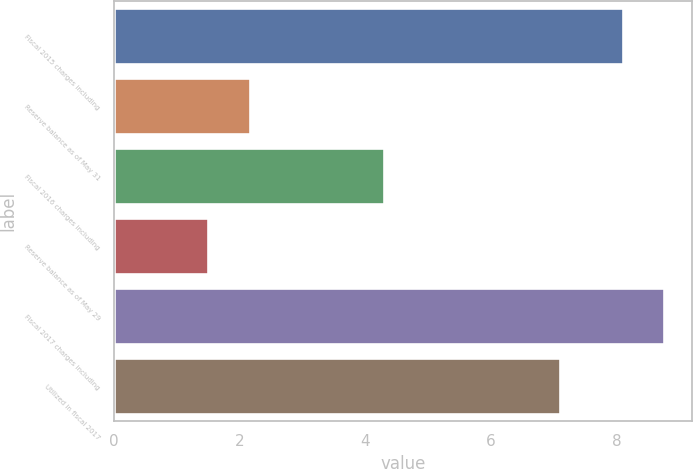<chart> <loc_0><loc_0><loc_500><loc_500><bar_chart><fcel>Fiscal 2015 charges including<fcel>Reserve balance as of May 31<fcel>Fiscal 2016 charges including<fcel>Reserve balance as of May 29<fcel>Fiscal 2017 charges including<fcel>Utilized in fiscal 2017<nl><fcel>8.1<fcel>2.16<fcel>4.3<fcel>1.5<fcel>8.76<fcel>7.1<nl></chart> 